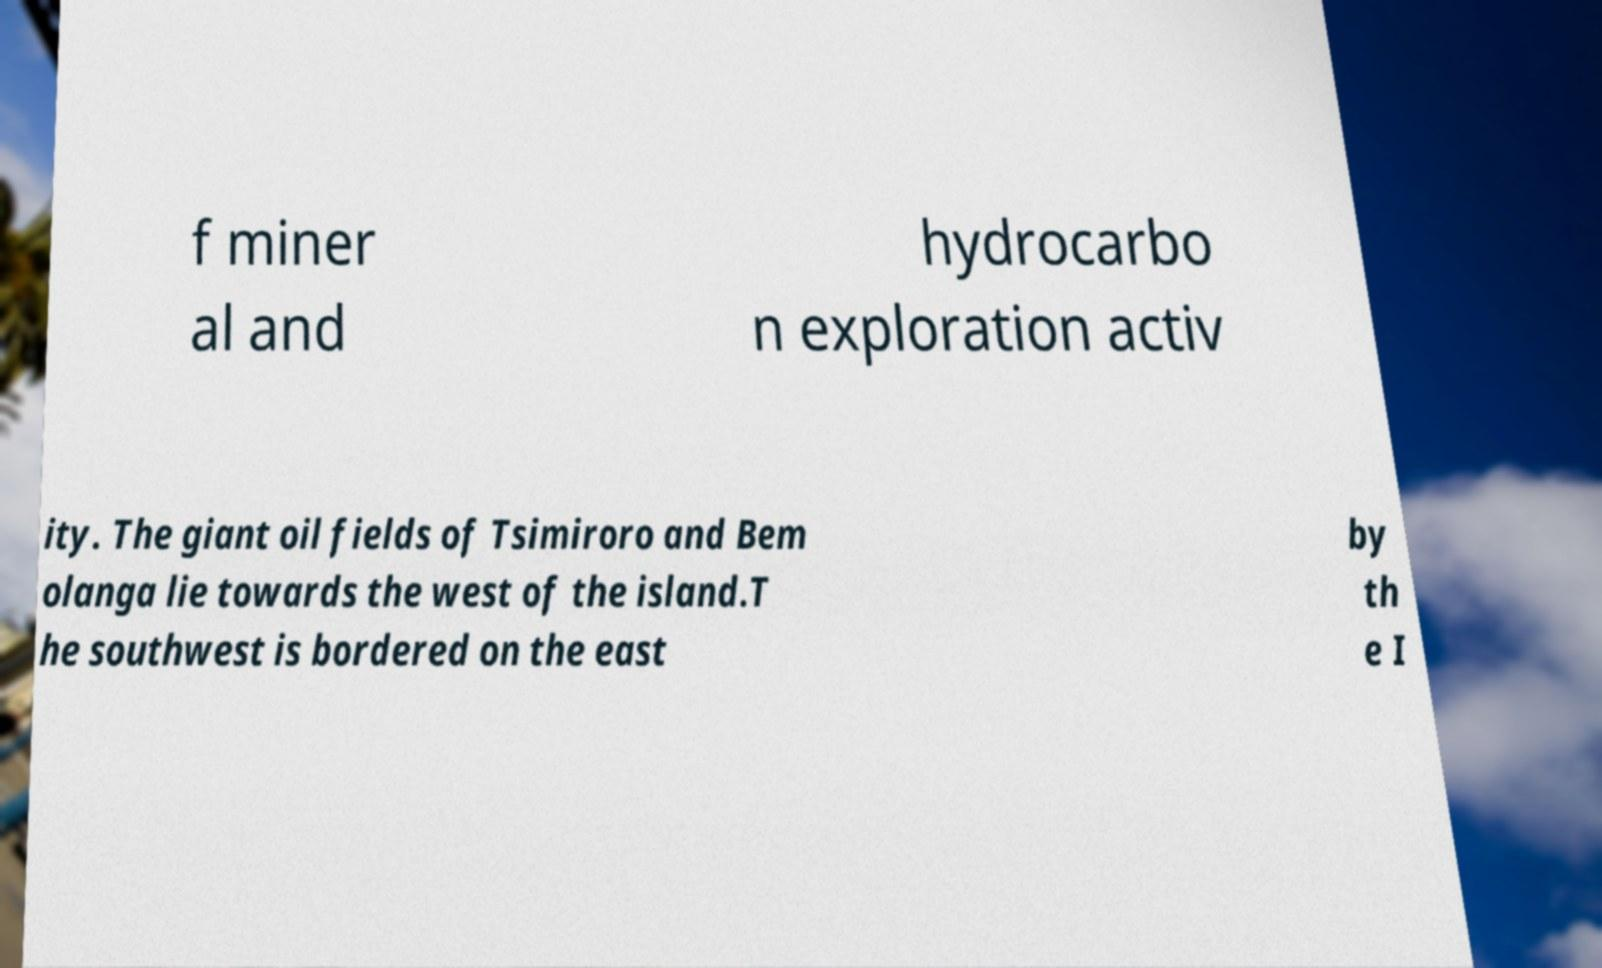There's text embedded in this image that I need extracted. Can you transcribe it verbatim? f miner al and hydrocarbo n exploration activ ity. The giant oil fields of Tsimiroro and Bem olanga lie towards the west of the island.T he southwest is bordered on the east by th e I 